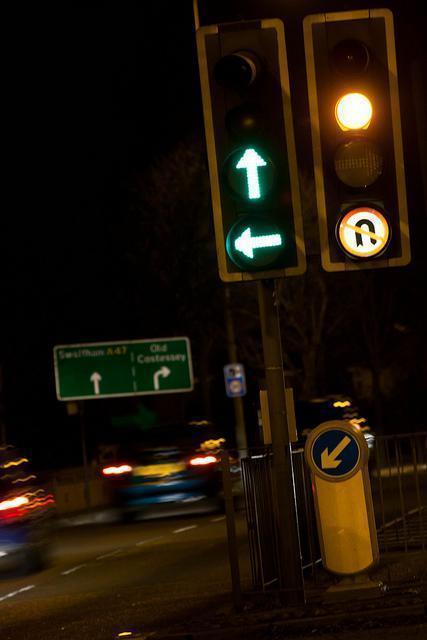What type of signs are these?
Choose the right answer and clarify with the format: 'Answer: answer
Rationale: rationale.'
Options: Direction signs, traffic signs, helpful signs, schoolzone signs. Answer: traffic signs.
Rationale: The signs direct traffic. 